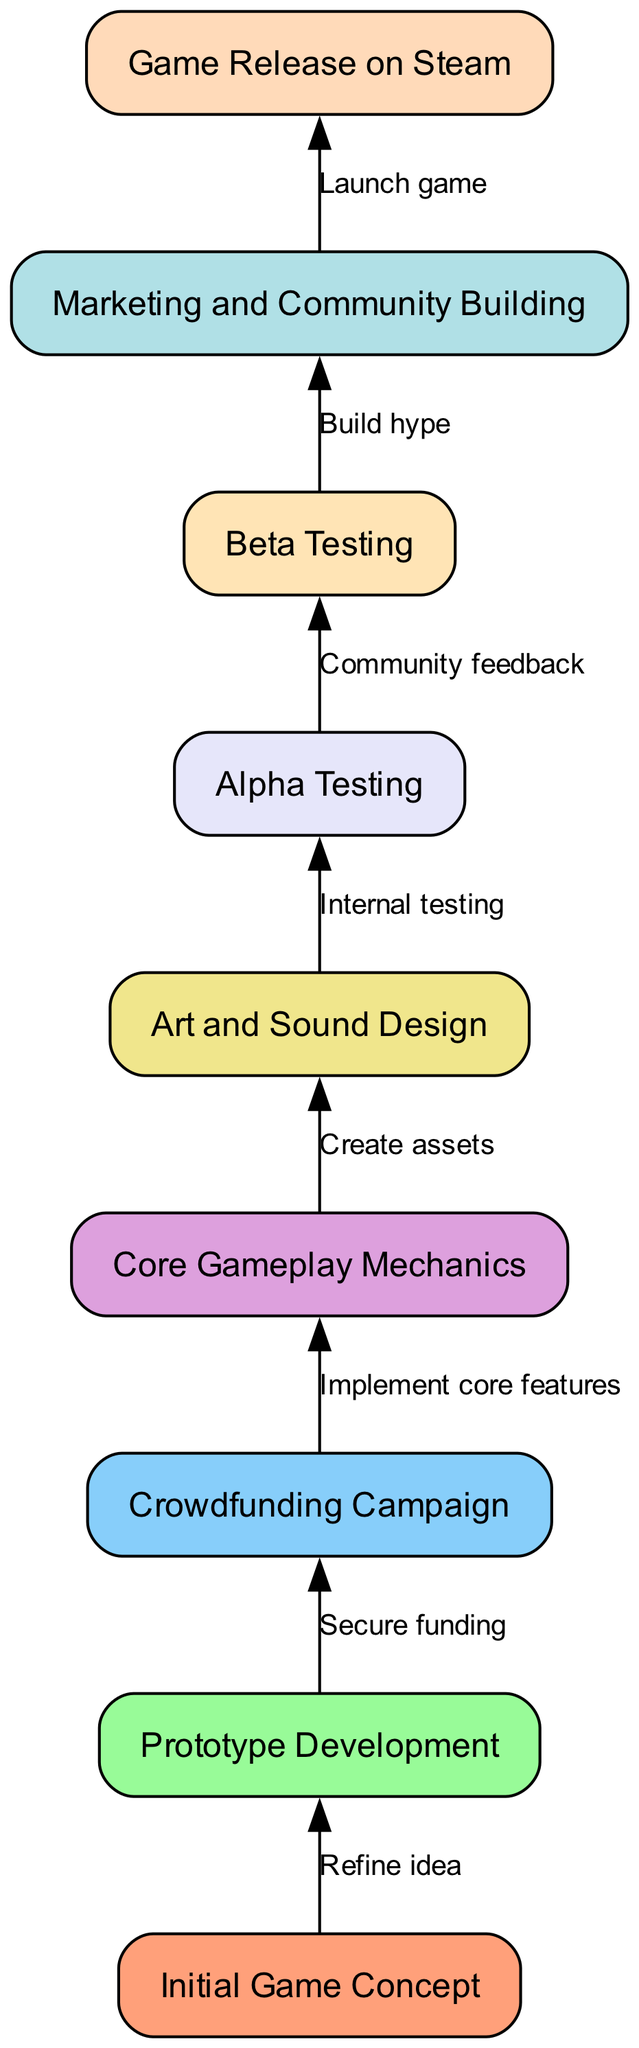What is the first stage in the indie game development flow? The diagram shows that the first stage is the "Initial Game Concept," which is the starting point of the development flow.
Answer: Initial Game Concept How many total nodes are in the flow chart? The diagram includes a total of nine distinct nodes, each representing a stage in the indie game development process.
Answer: 9 What follows the "Prototype Development" stage? According to the flow chart, following "Prototype Development" is the "Crowdfunding Campaign," as indicated by the direct connection from one to the other.
Answer: Crowdfunding Campaign What step occurs after "Alpha Testing"? The diagram indicates that "Beta Testing" comes next after "Alpha Testing," forming a sequential flow in the development process.
Answer: Beta Testing What is the final stage of the indie game development process? The last stage, as portrayed in the flow chart, is "Game Release on Steam," concluding the development journey.
Answer: Game Release on Steam What edge connects "Core Gameplay Mechanics" and "Art and Sound Design"? The edge connecting these two nodes is labeled "Create assets," representing the transition from implementing gameplay mechanics to designing the assets for the game.
Answer: Create assets Which stage directly comes after "Community feedback"? The flow chart shows that "Build hype" directly follows the "Community feedback" stage, highlighting the importance of community involvement in marketing.
Answer: Build hype What is the relationship between "Crowdfunding Campaign" and "Core Gameplay Mechanics"? The flow indicates that "Crowdfunding Campaign" leads to "Core Gameplay Mechanics," with the label "Implement core features" describing the purpose of this connection.
Answer: Implement core features What color represents the "Art and Sound Design" node? The "Art and Sound Design" node, which is the fifth node in the flow chart, is filled with the color associated with the fifth position in the defined color palette.
Answer: Lavender 